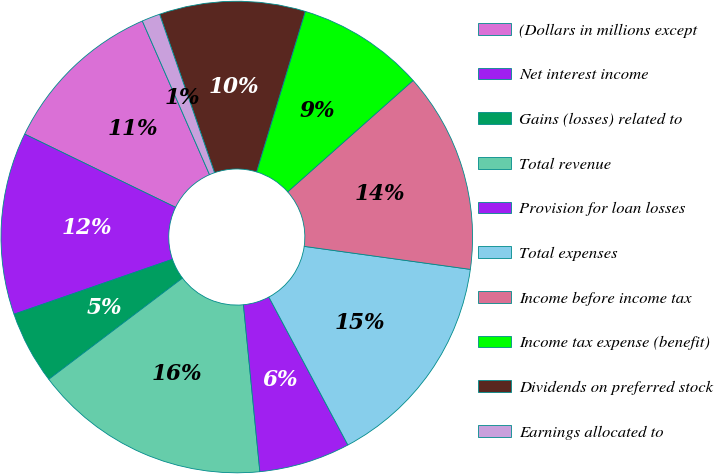Convert chart. <chart><loc_0><loc_0><loc_500><loc_500><pie_chart><fcel>(Dollars in millions except<fcel>Net interest income<fcel>Gains (losses) related to<fcel>Total revenue<fcel>Provision for loan losses<fcel>Total expenses<fcel>Income before income tax<fcel>Income tax expense (benefit)<fcel>Dividends on preferred stock<fcel>Earnings allocated to<nl><fcel>11.25%<fcel>12.5%<fcel>5.0%<fcel>16.25%<fcel>6.25%<fcel>15.0%<fcel>13.75%<fcel>8.75%<fcel>10.0%<fcel>1.25%<nl></chart> 